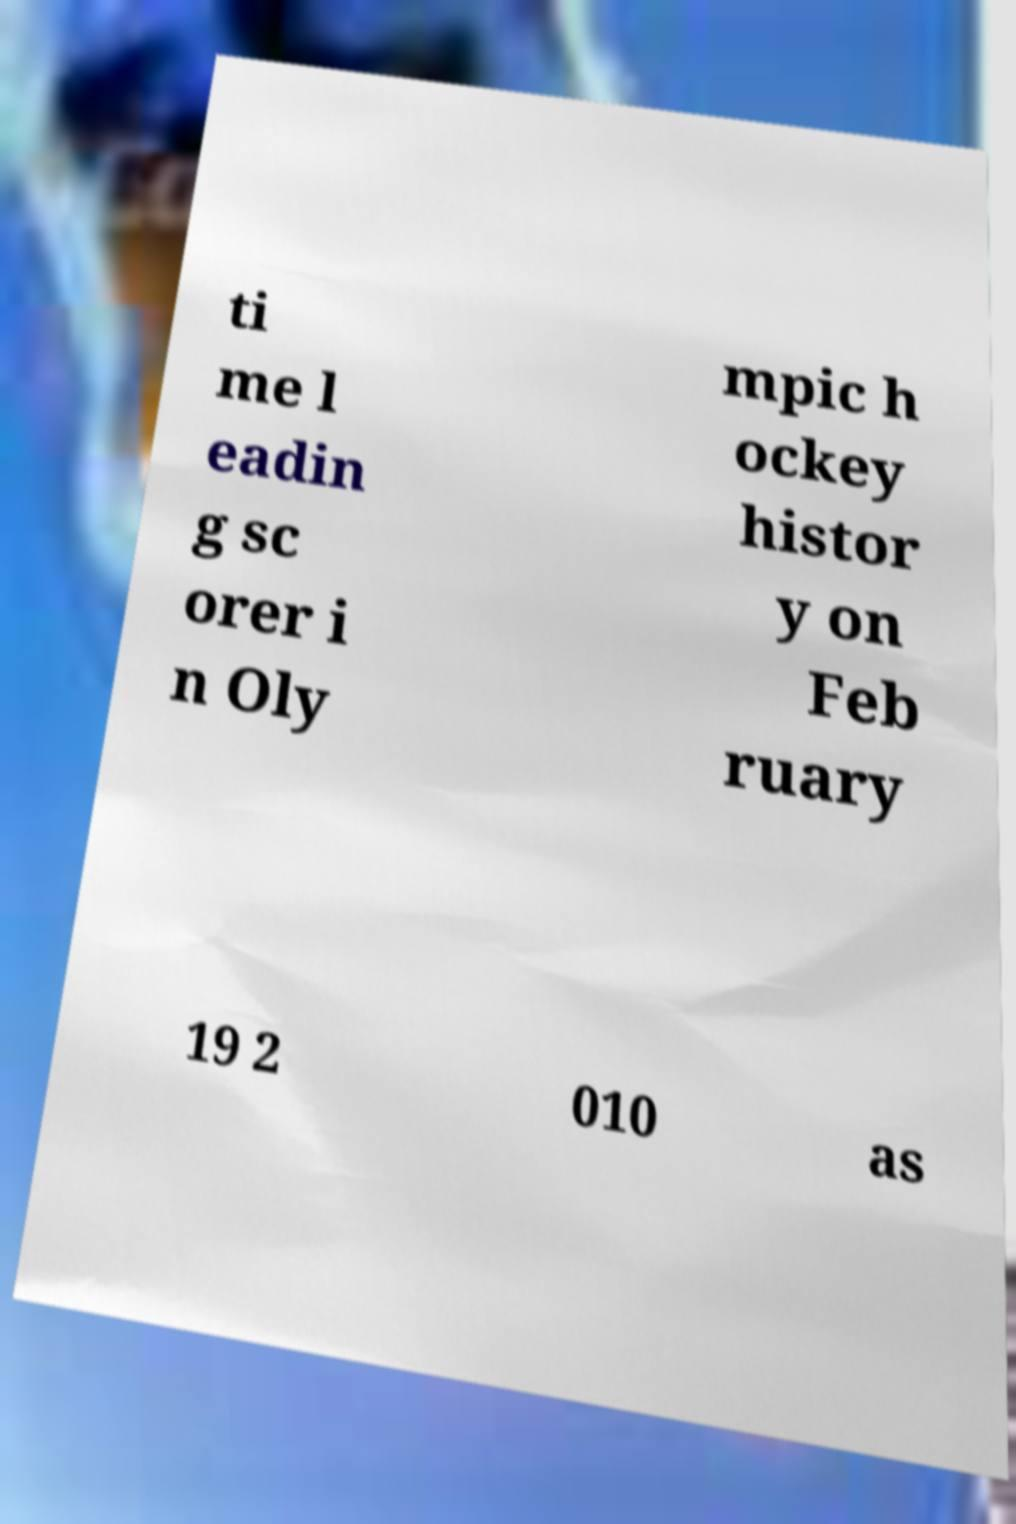Could you extract and type out the text from this image? ti me l eadin g sc orer i n Oly mpic h ockey histor y on Feb ruary 19 2 010 as 